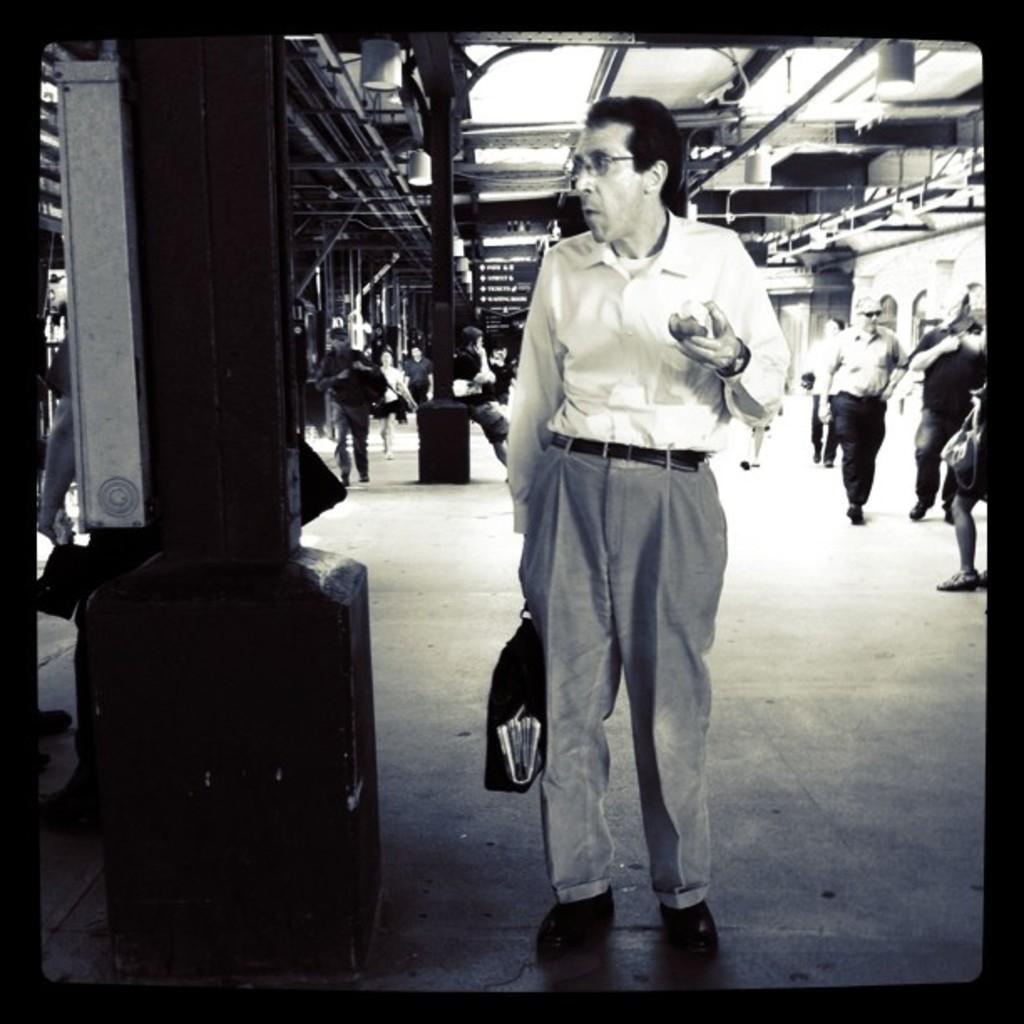Could you give a brief overview of what you see in this image? This is a black and white image. In this image we can see some persons sitting and some are walking on the floor. In the background there are grills and poles. 